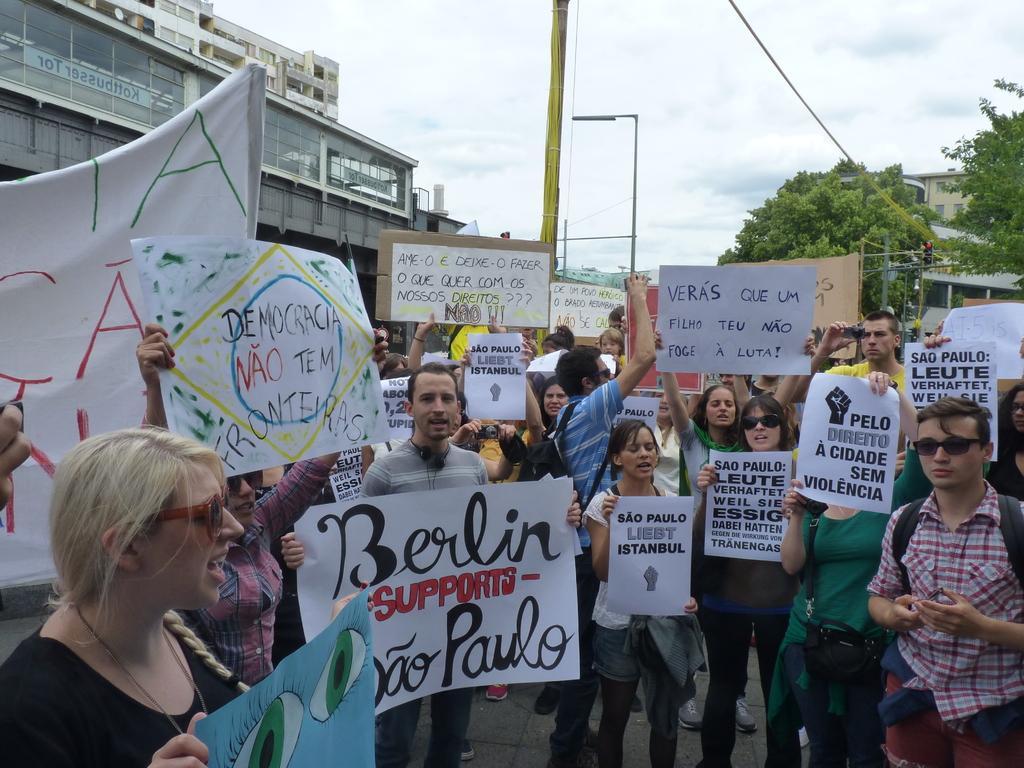Could you give a brief overview of what you see in this image? In this picture we can see goggles, bags, cameras, posters and a group of people standing on the road and at the back of them we can see trees, buildings, traffic signal and some objects and in the background we can see the sky with clouds. 